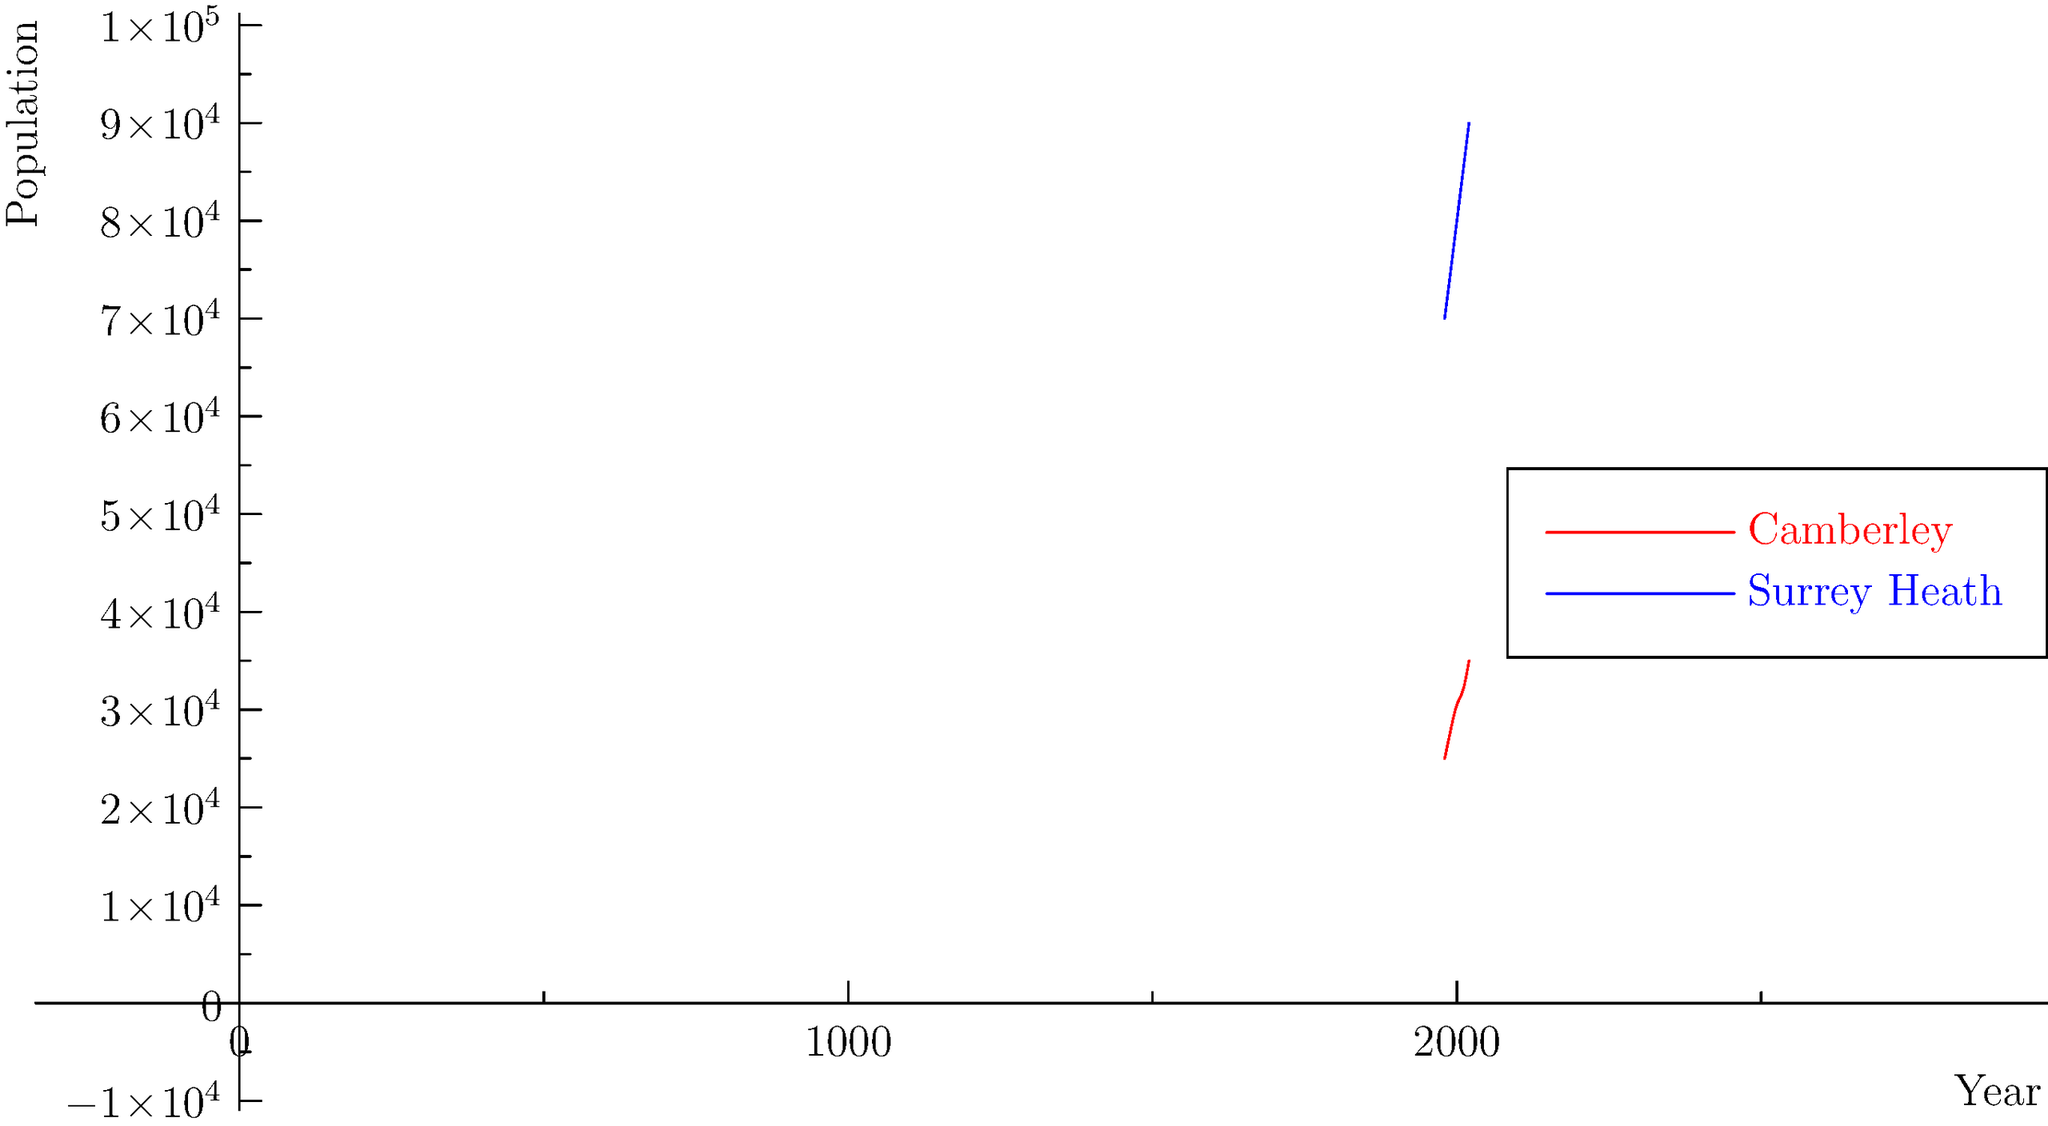Based on the line graph showing population growth trends for Camberley and Surrey Heath from 1980 to 2020, calculate the average decadal growth rate for Camberley. How does this compare to the overall growth rate of Surrey Heath during the same period? To solve this question, we need to follow these steps:

1. Calculate the total population growth for Camberley from 1980 to 2020:
   Population in 2020: 35,000
   Population in 1980: 25,000
   Total growth = 35,000 - 25,000 = 10,000

2. Calculate the average decadal growth for Camberley:
   Number of decades = (2020 - 1980) / 10 = 4
   Average decadal growth = 10,000 / 4 = 2,500

3. Calculate the average decadal growth rate for Camberley:
   Initial population (1980) = 25,000
   Average decadal growth rate = (2,500 / 25,000) * 100 = 10%

4. Calculate the overall growth rate for Surrey Heath:
   Population in 2020: 90,000
   Population in 1980: 70,000
   Total growth = 90,000 - 70,000 = 20,000
   Overall growth rate = (20,000 / 70,000) * 100 ≈ 28.57%

5. Compare the growth rates:
   Camberley's average decadal growth rate: 10%
   Surrey Heath's overall growth rate: 28.57%

The average decadal growth rate for Camberley (10%) is lower than the overall growth rate of Surrey Heath (28.57%) for the entire 40-year period. This suggests that while Camberley has been growing steadily, Surrey Heath as a whole has experienced faster population growth.
Answer: Camberley's average decadal growth rate is 10%, lower than Surrey Heath's overall growth rate of 28.57%. 